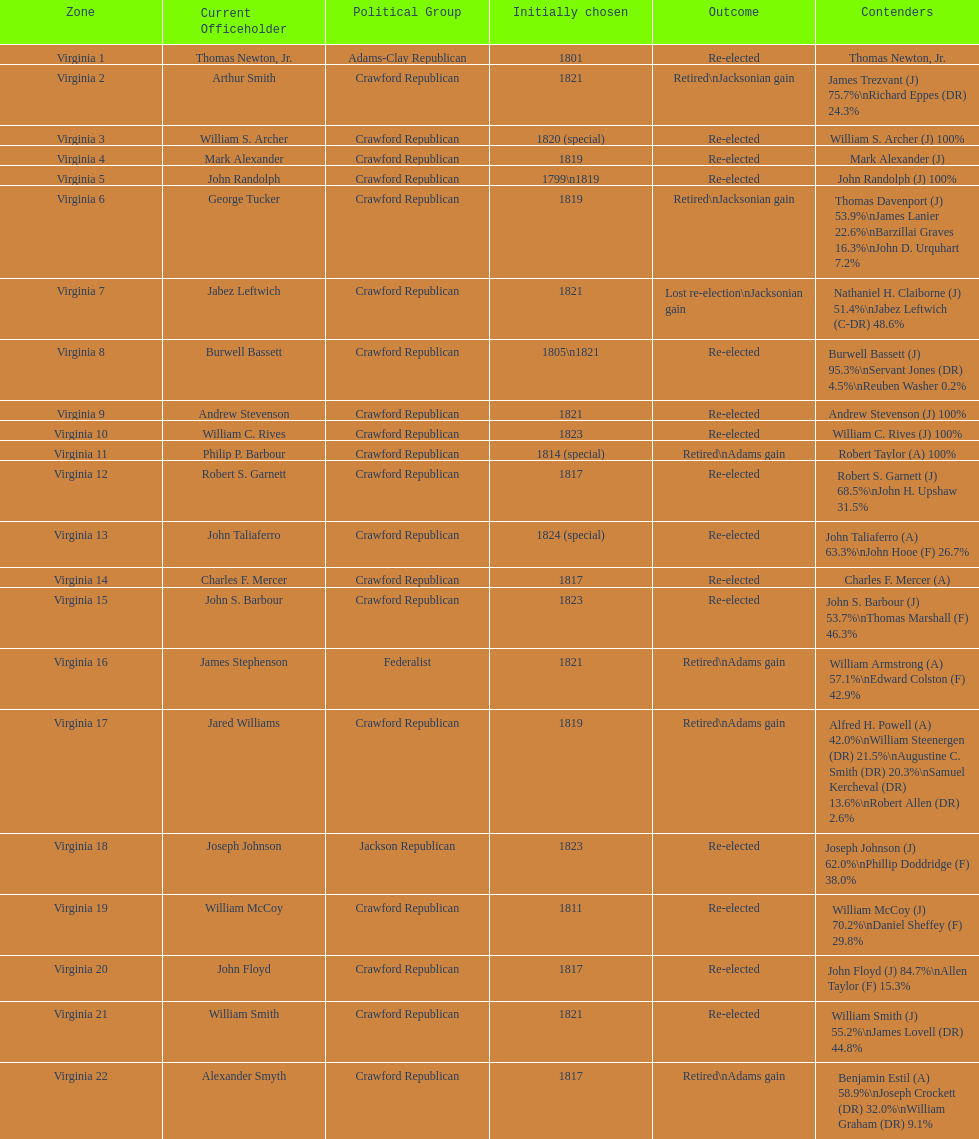Name the only candidate that was first elected in 1811. William McCoy. 